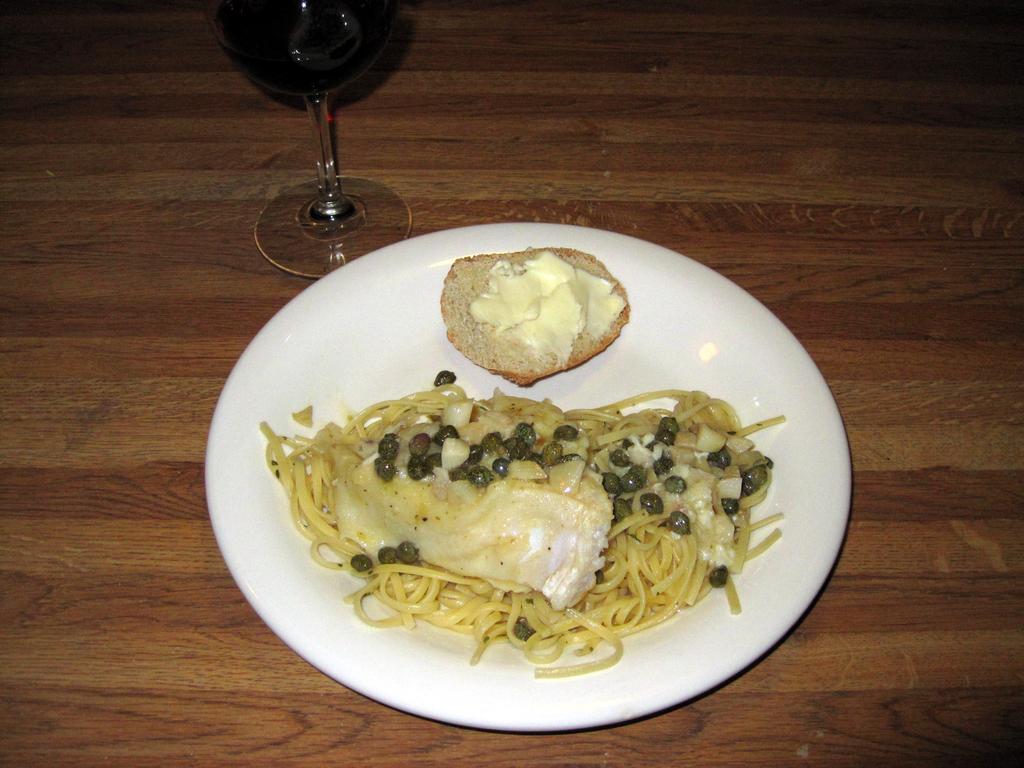How would you summarize this image in a sentence or two? In this image there is some food item on a plate, beside the plate there is a glass of wine on a wooden platform. 